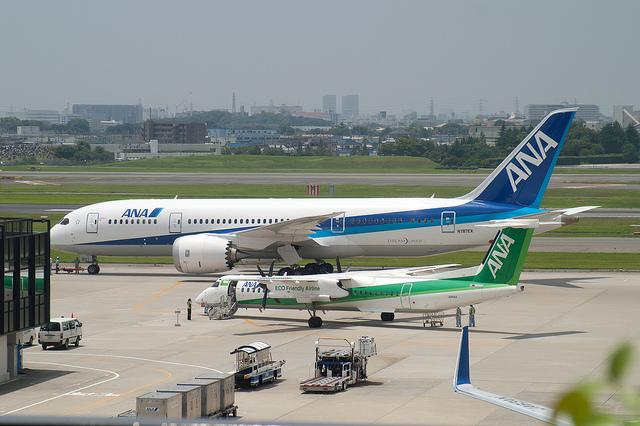Which vehicle can carry the most volume of supplies? Please explain your reasoning. blue plane. It is the largest vehicle with the most space inside 